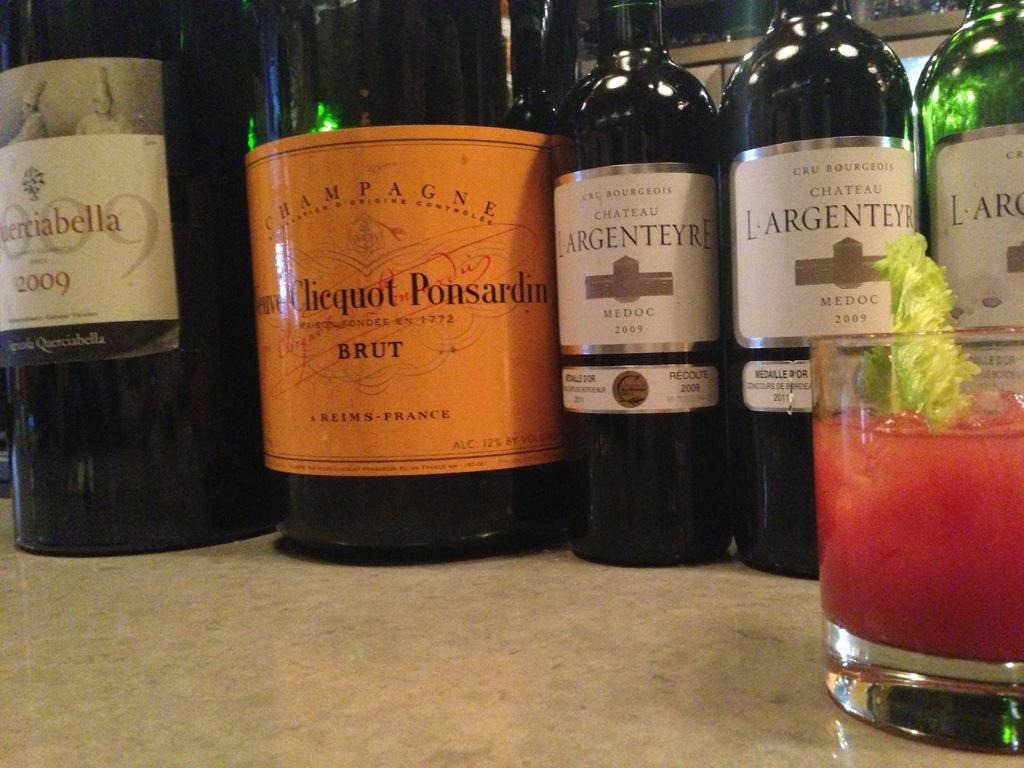<image>
Present a compact description of the photo's key features. A bottle of year 2009 wine sits to the left of other bottles of wine. 